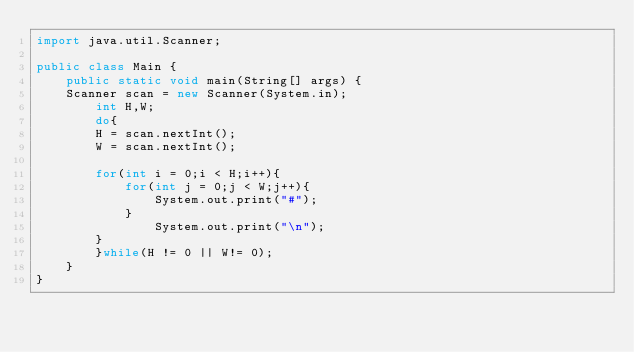Convert code to text. <code><loc_0><loc_0><loc_500><loc_500><_Java_>import java.util.Scanner;

public class Main {
    public static void main(String[] args) {
	Scanner scan = new Scanner(System.in);
		int H,W;
		do{
		H = scan.nextInt();
		W = scan.nextInt();

		for(int i = 0;i < H;i++){
			for(int j = 0;j < W;j++){
				System.out.print("#");
			}
				System.out.print("\n");
		}
		}while(H != 0 || W!= 0);
	}
}</code> 